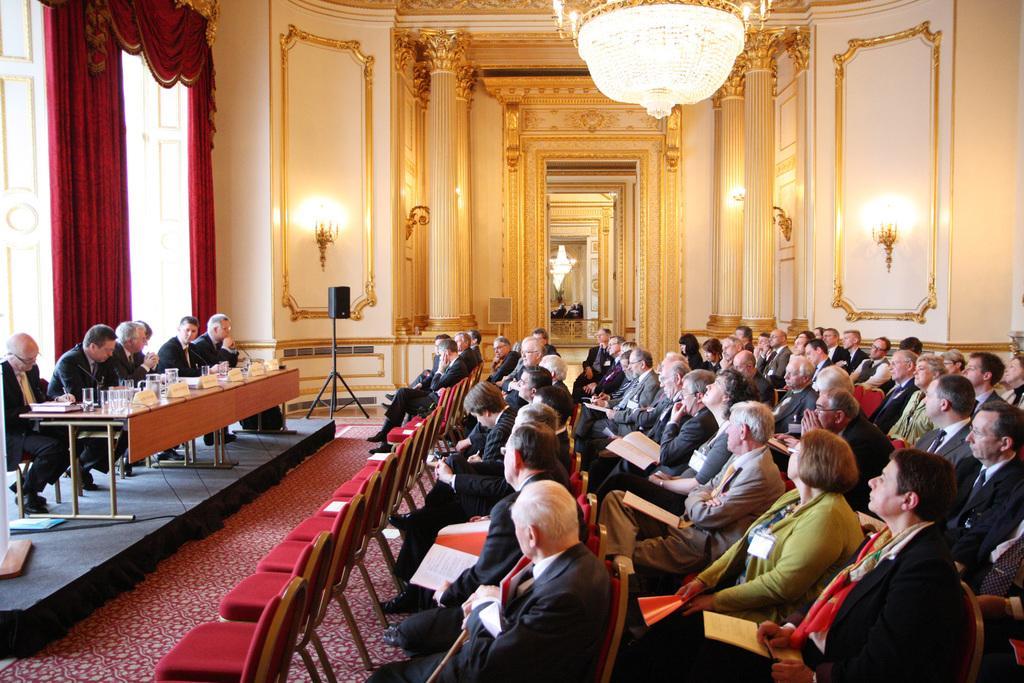Could you give a brief overview of what you see in this image? In this image we can see many people sitting on the chairs and holding some objects in their hands. There are few people sitting near a table at the left side of the image. There are few lumps on the walls. We can see the reflection of few people and lights on the mirror. There is a loudspeaker in the image. There are many chairs in the image. There are few objects on the ground at the left side of the image. 